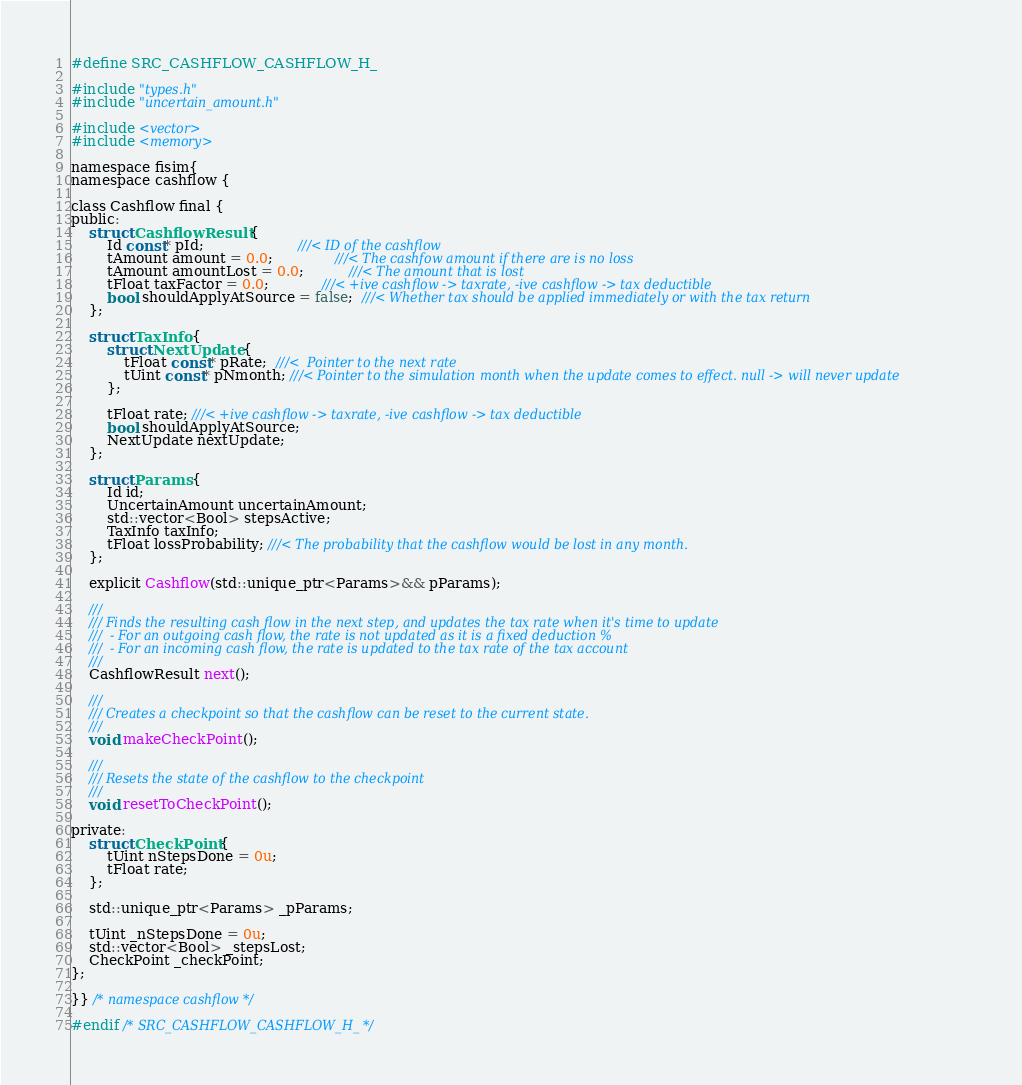<code> <loc_0><loc_0><loc_500><loc_500><_C_>#define SRC_CASHFLOW_CASHFLOW_H_

#include "types.h"
#include "uncertain_amount.h"

#include <vector>
#include <memory>

namespace fisim{
namespace cashflow {

class Cashflow final {
public:
	struct CashflowResult {
		Id const* pId;                     ///< ID of the cashflow
		tAmount amount = 0.0;              ///< The cashfow amount if there are is no loss
		tAmount amountLost = 0.0;          ///< The amount that is lost
		tFloat taxFactor = 0.0;            ///< +ive cashflow -> taxrate, -ive cashflow -> tax deductible
		bool shouldApplyAtSource = false;  ///< Whether tax should be applied immediately or with the tax return
	};

	struct TaxInfo {
		struct NextUpdate {
			tFloat const* pRate;  ///<  Pointer to the next rate
			tUint const* pNmonth; ///< Pointer to the simulation month when the update comes to effect. null -> will never update
		};

		tFloat rate; ///< +ive cashflow -> taxrate, -ive cashflow -> tax deductible
		bool shouldApplyAtSource;
		NextUpdate nextUpdate;
	};

	struct Params {
		Id id;
		UncertainAmount uncertainAmount;
		std::vector<Bool> stepsActive;
		TaxInfo taxInfo;
		tFloat lossProbability; ///< The probability that the cashflow would be lost in any month.
	};

	explicit Cashflow(std::unique_ptr<Params>&& pParams);

	///
	/// Finds the resulting cash flow in the next step, and updates the tax rate when it's time to update
	///  - For an outgoing cash flow, the rate is not updated as it is a fixed deduction %
	///  - For an incoming cash flow, the rate is updated to the tax rate of the tax account
	///
	CashflowResult next();

	///
	/// Creates a checkpoint so that the cashflow can be reset to the current state.
	///
	void makeCheckPoint();

	///
	/// Resets the state of the cashflow to the checkpoint
	///
	void resetToCheckPoint();

private:
	struct CheckPoint {
		tUint nStepsDone = 0u;
		tFloat rate;
	};

	std::unique_ptr<Params> _pParams;

	tUint _nStepsDone = 0u;
	std::vector<Bool> _stepsLost;
	CheckPoint _checkPoint;
};

}} /* namespace cashflow */

#endif /* SRC_CASHFLOW_CASHFLOW_H_ */
</code> 